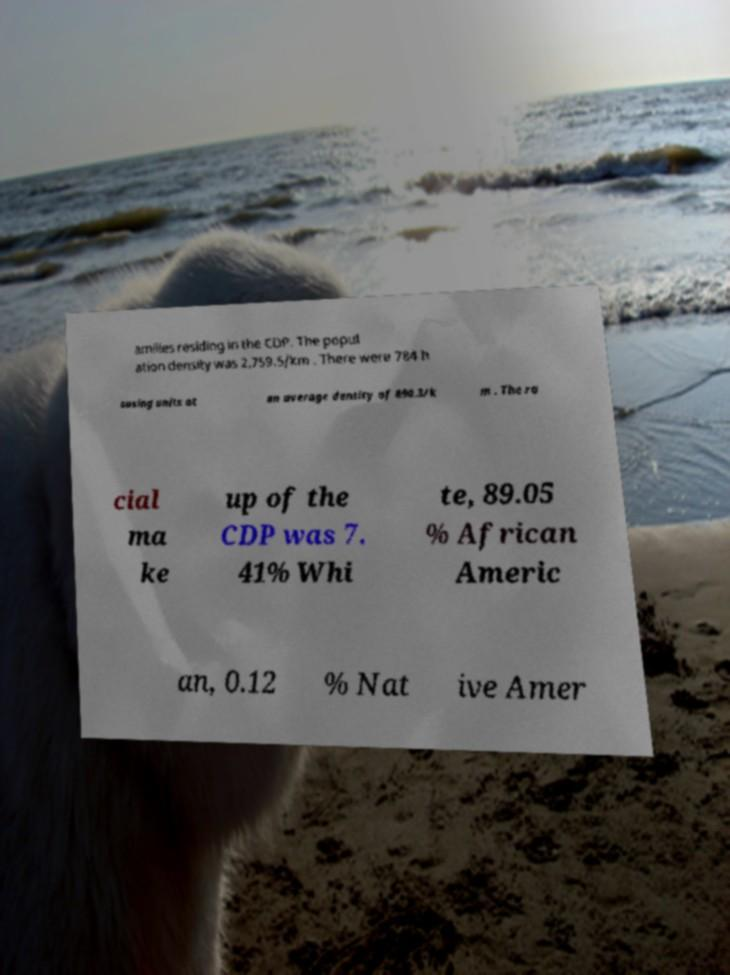Please identify and transcribe the text found in this image. amilies residing in the CDP. The popul ation density was 2,759.5/km . There were 784 h ousing units at an average density of 890.3/k m . The ra cial ma ke up of the CDP was 7. 41% Whi te, 89.05 % African Americ an, 0.12 % Nat ive Amer 